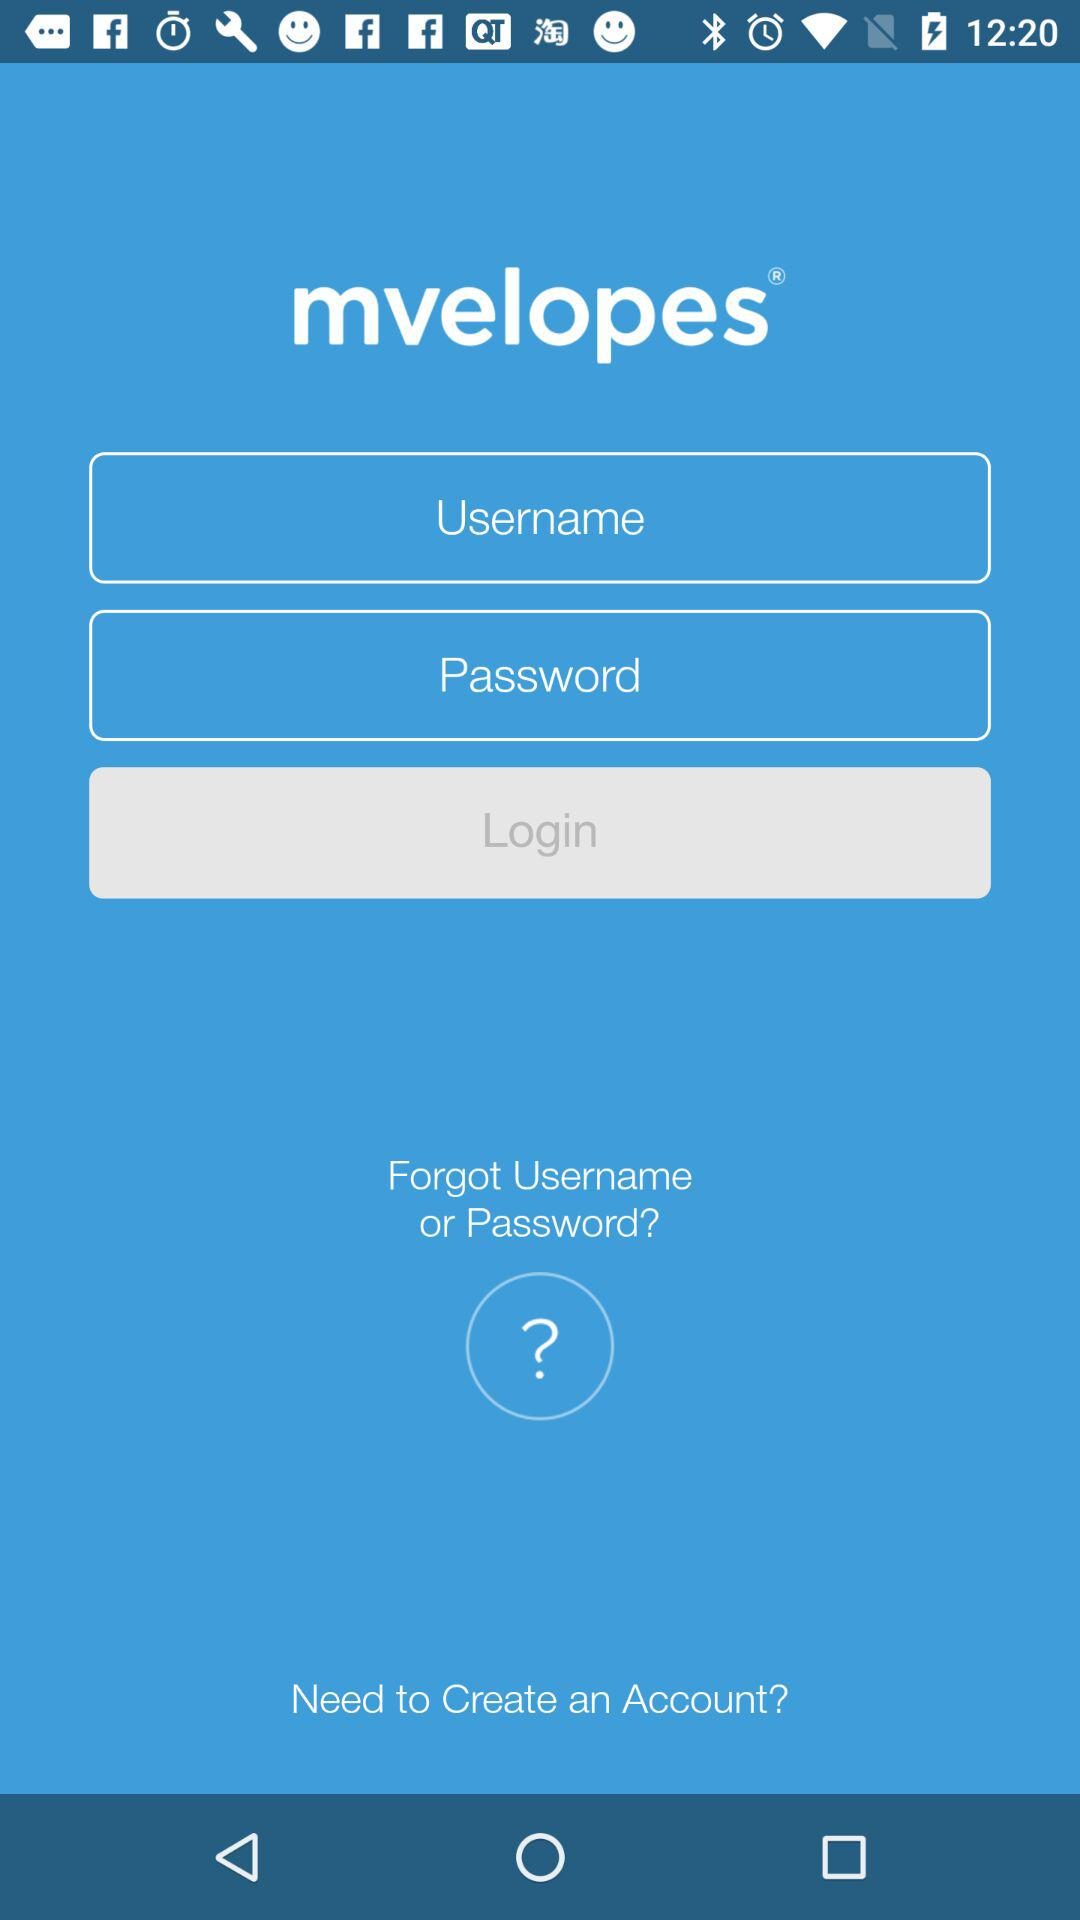What is the name of the application? The name of the application is "mvelopes". 